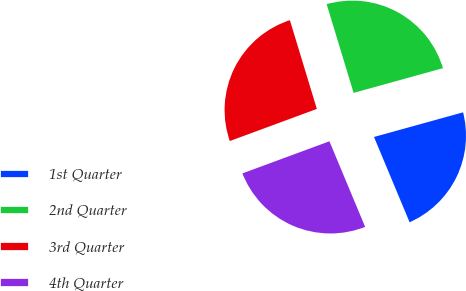<chart> <loc_0><loc_0><loc_500><loc_500><pie_chart><fcel>1st Quarter<fcel>2nd Quarter<fcel>3rd Quarter<fcel>4th Quarter<nl><fcel>23.0%<fcel>25.4%<fcel>25.93%<fcel>25.67%<nl></chart> 